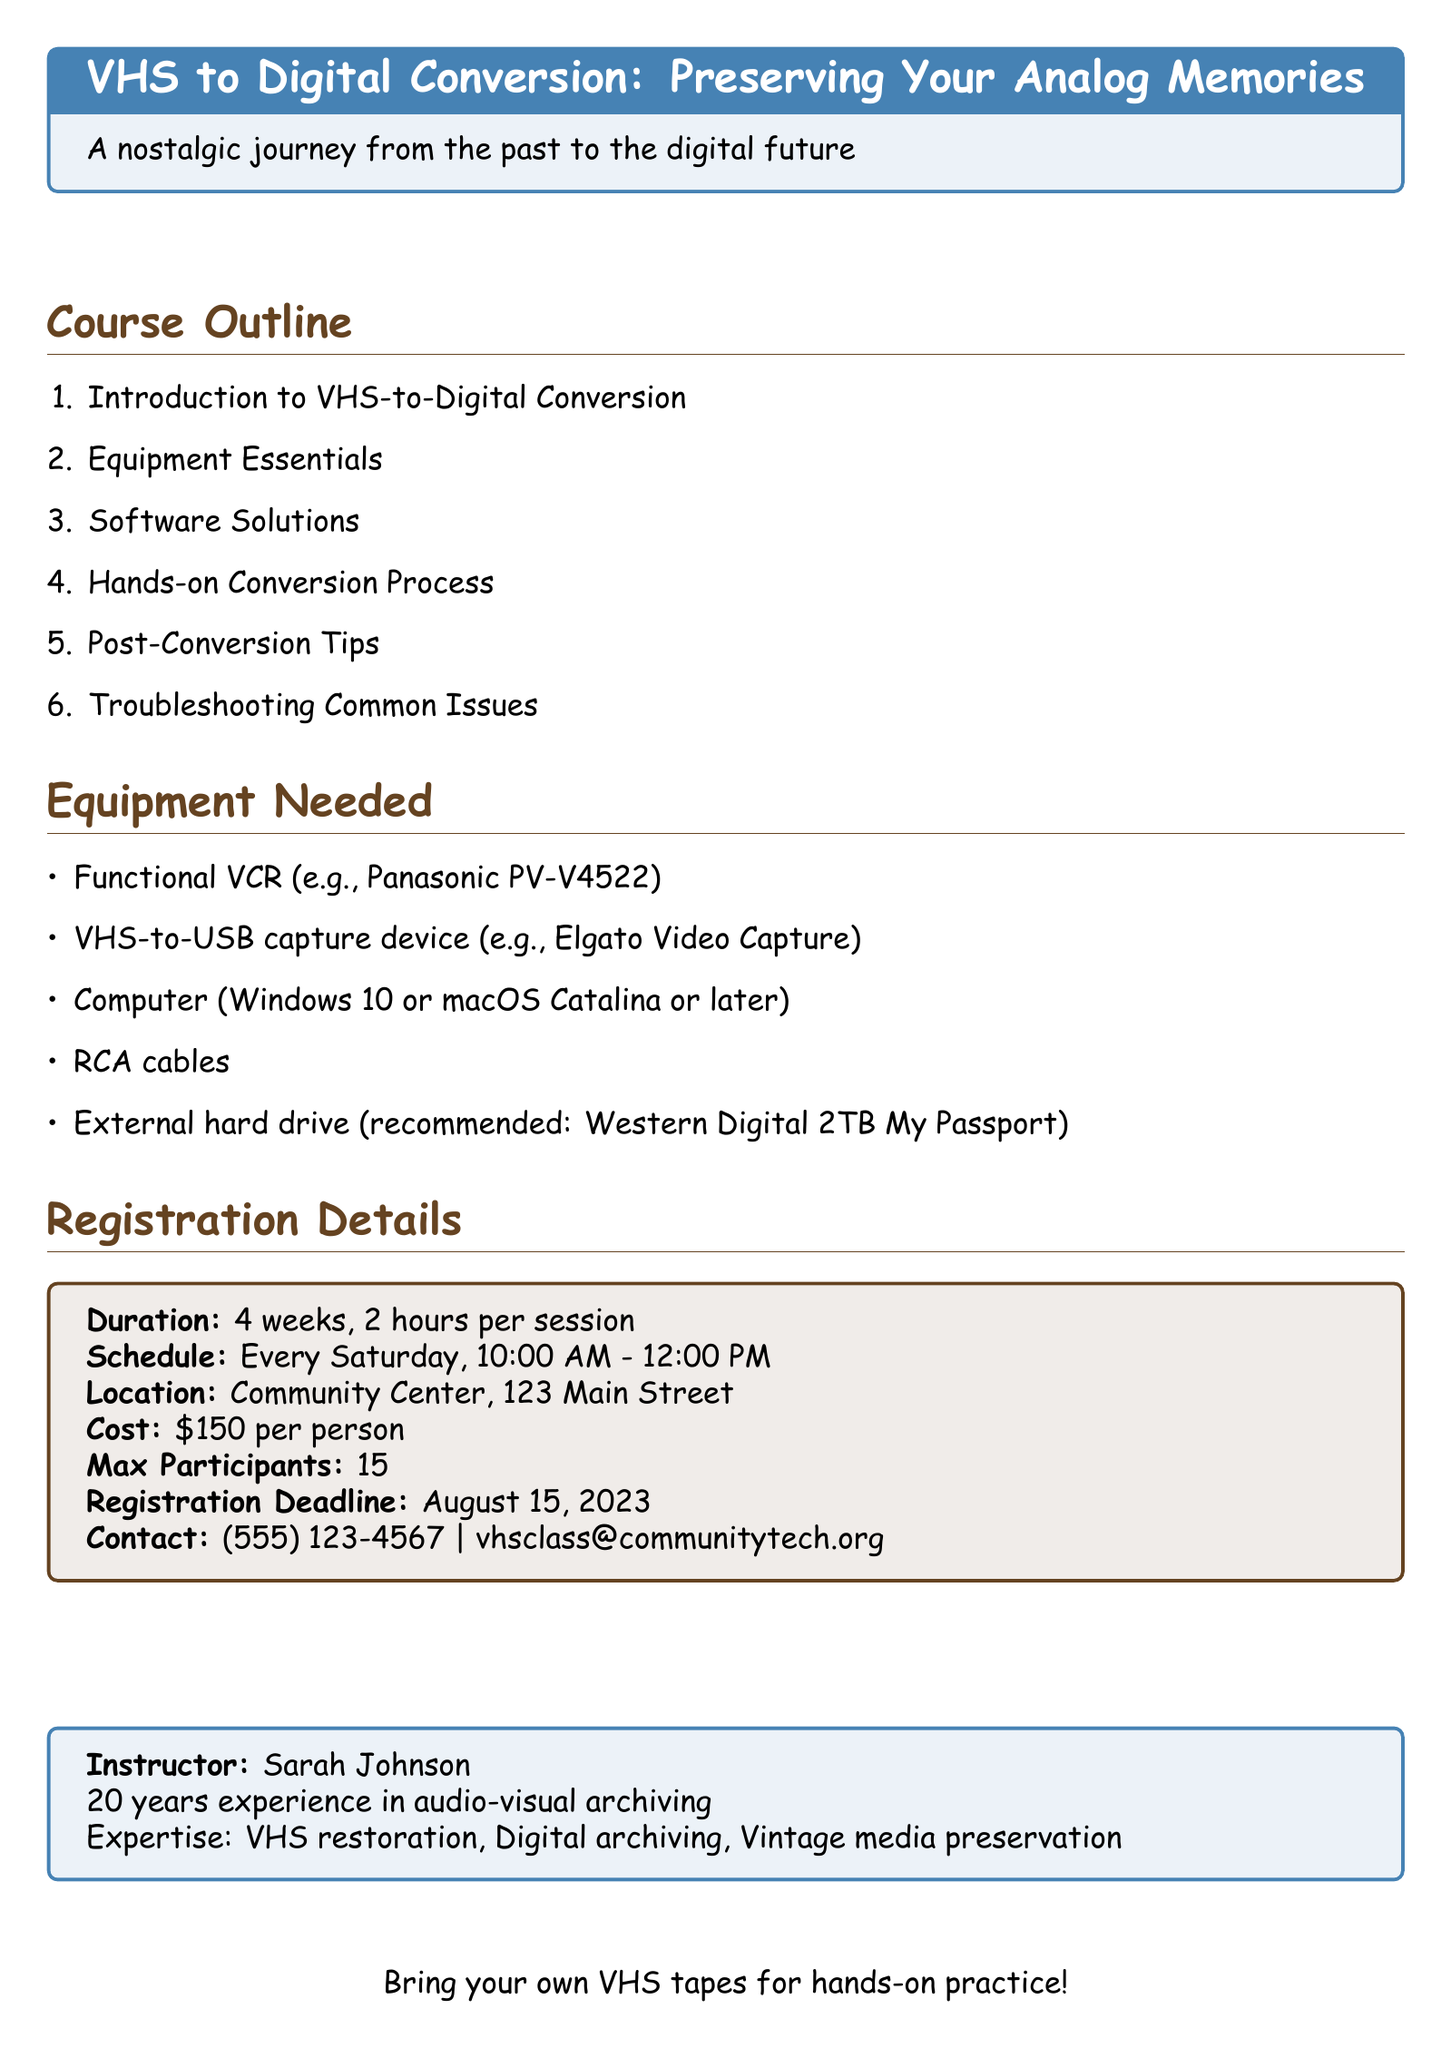What is the course title? The course title is explicitly stated in the document as "VHS to Digital Conversion: Preserving Your Analog Memories."
Answer: VHS to Digital Conversion: Preserving Your Analog Memories Who is the instructor? The instructor's name is provided in the document, which is "Sarah Johnson."
Answer: Sarah Johnson How many weeks does the course last? The document specifies the course duration as "4 weeks."
Answer: 4 weeks What is the location of the class? The document clearly mentions the location is "Community Center, 123 Main Street."
Answer: Community Center, 123 Main Street What is the maximum number of participants allowed? According to the document, the maximum number of participants is "15."
Answer: 15 What equipment is needed for the course? The document lists several items, one of which is "Functional VCR (e.g., Panasonic PV-V4522)."
Answer: Functional VCR (e.g., Panasonic PV-V4522) What time does the class start? The class schedule indicates that sessions start at "10:00 AM."
Answer: 10:00 AM What is the registration deadline? The document specifies that the registration deadline is "August 15, 2023."
Answer: August 15, 2023 What software is included as a free option? The document mentions "VLC Media Player and OBS Studio" as free software options.
Answer: VLC Media Player and OBS Studio 